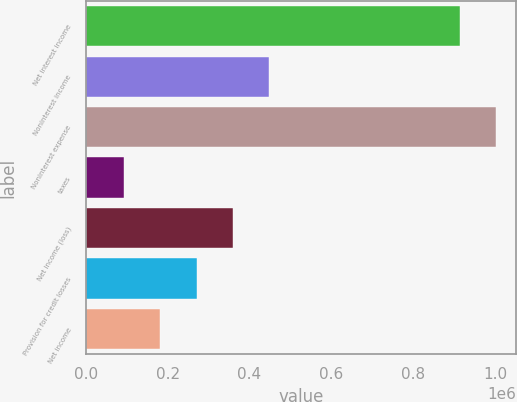Convert chart. <chart><loc_0><loc_0><loc_500><loc_500><bar_chart><fcel>Net interest income<fcel>Noninterest income<fcel>Noninterest expense<fcel>taxes<fcel>Net income (loss)<fcel>Provision for credit losses<fcel>Net income<nl><fcel>912992<fcel>448548<fcel>1.00195e+06<fcel>92722<fcel>359592<fcel>270635<fcel>181679<nl></chart> 